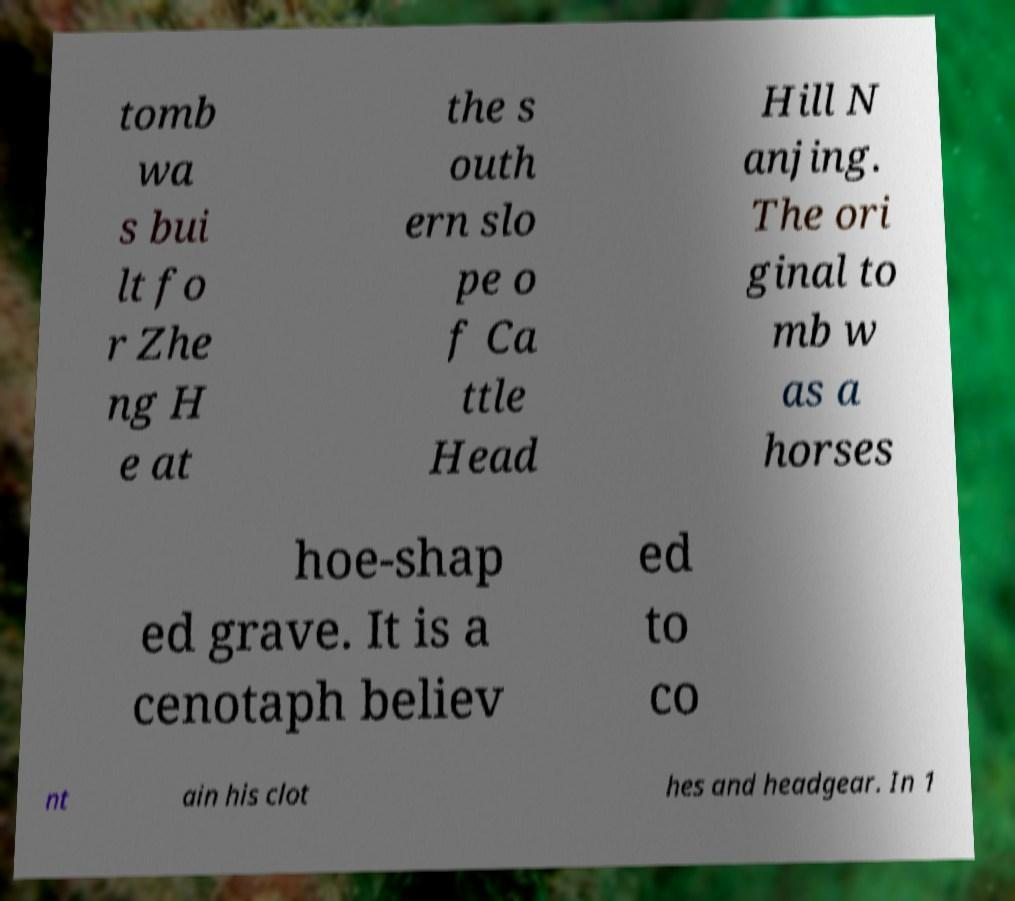What messages or text are displayed in this image? I need them in a readable, typed format. tomb wa s bui lt fo r Zhe ng H e at the s outh ern slo pe o f Ca ttle Head Hill N anjing. The ori ginal to mb w as a horses hoe-shap ed grave. It is a cenotaph believ ed to co nt ain his clot hes and headgear. In 1 